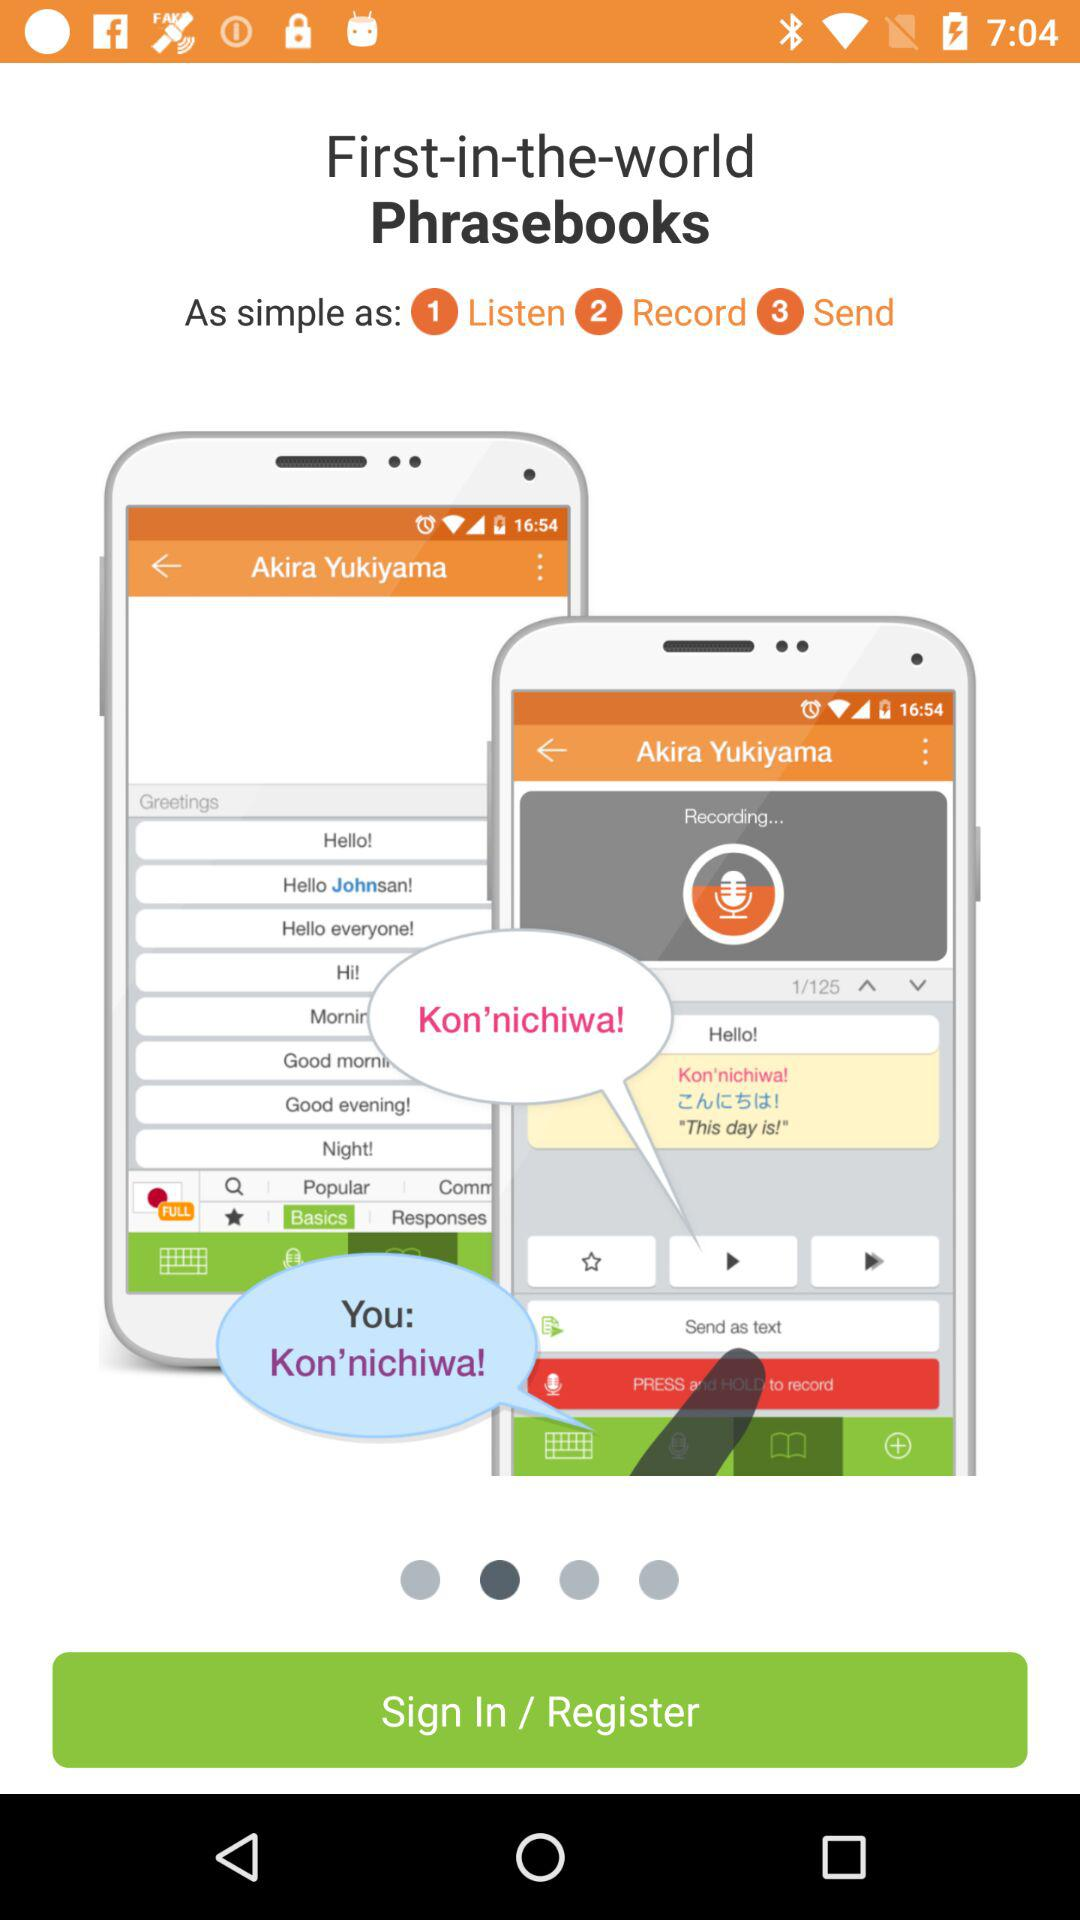What is the name of the application? The name of the application is "Phrasebooks". 